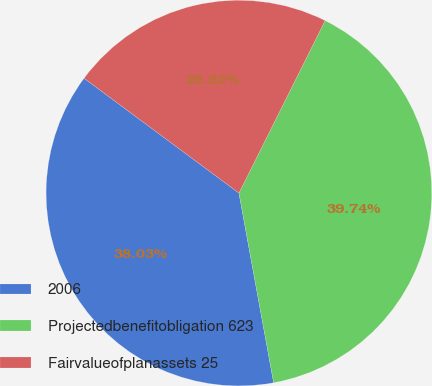Convert chart to OTSL. <chart><loc_0><loc_0><loc_500><loc_500><pie_chart><fcel>2006<fcel>Projectedbenefitobligation 623<fcel>Fairvalueofplanassets 25<nl><fcel>38.03%<fcel>39.74%<fcel>22.22%<nl></chart> 